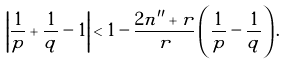Convert formula to latex. <formula><loc_0><loc_0><loc_500><loc_500>\left | \frac { 1 } { p } + \frac { 1 } { q } - 1 \right | < 1 - \frac { 2 n ^ { \prime \prime } + r } { r } \left ( \frac { 1 } { p } - \frac { 1 } { q } \right ) .</formula> 